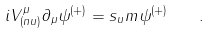Convert formula to latex. <formula><loc_0><loc_0><loc_500><loc_500>i V ^ { \mu } _ { ( n u ) } \partial _ { \mu } \psi ^ { ( + ) } = s _ { u } m \psi ^ { ( + ) } \quad .</formula> 